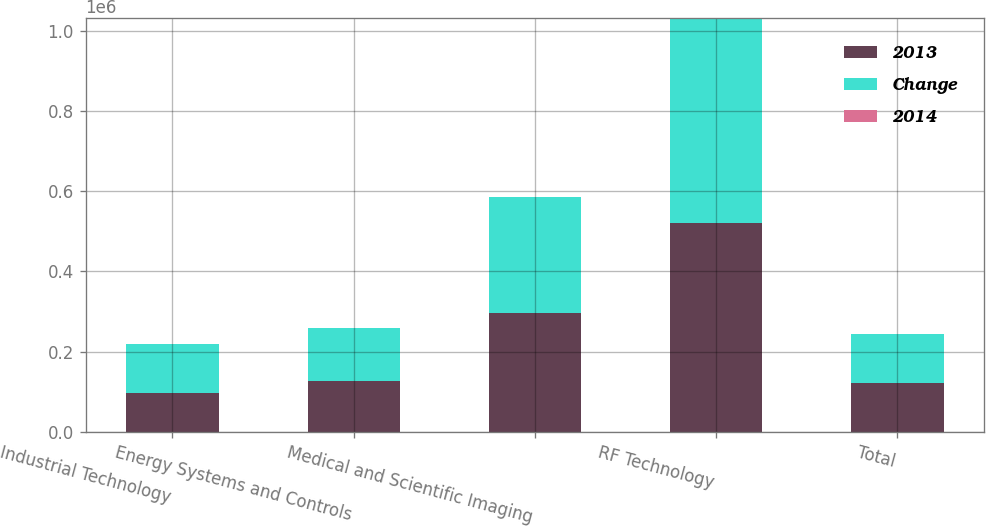Convert chart to OTSL. <chart><loc_0><loc_0><loc_500><loc_500><stacked_bar_chart><ecel><fcel>Industrial Technology<fcel>Energy Systems and Controls<fcel>Medical and Scientific Imaging<fcel>RF Technology<fcel>Total<nl><fcel>2013<fcel>97507<fcel>126838<fcel>296098<fcel>520727<fcel>121943<nl><fcel>Change<fcel>121943<fcel>131799<fcel>290435<fcel>510553<fcel>121943<nl><fcel>2014<fcel>20<fcel>3.8<fcel>1.9<fcel>2<fcel>1.3<nl></chart> 